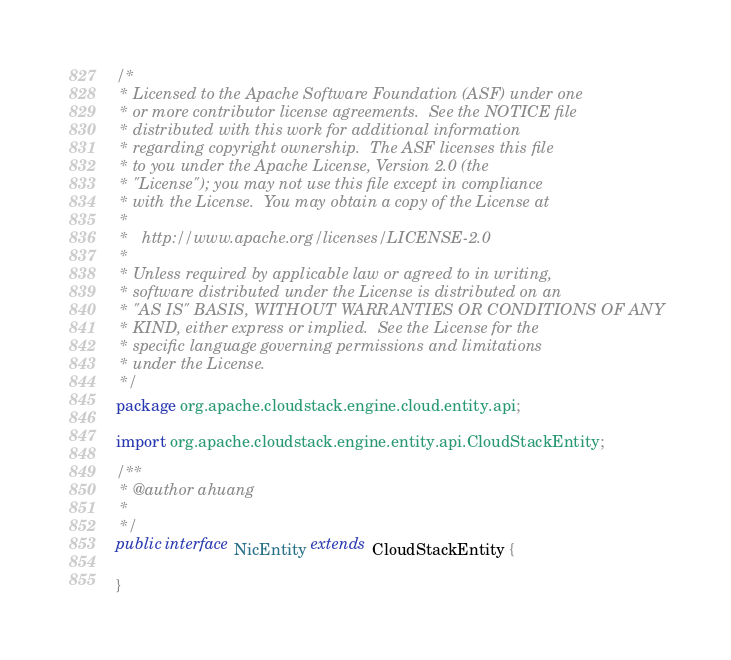Convert code to text. <code><loc_0><loc_0><loc_500><loc_500><_Java_>/*
 * Licensed to the Apache Software Foundation (ASF) under one
 * or more contributor license agreements.  See the NOTICE file
 * distributed with this work for additional information
 * regarding copyright ownership.  The ASF licenses this file
 * to you under the Apache License, Version 2.0 (the
 * "License"); you may not use this file except in compliance
 * with the License.  You may obtain a copy of the License at
 *
 *   http://www.apache.org/licenses/LICENSE-2.0
 *
 * Unless required by applicable law or agreed to in writing,
 * software distributed under the License is distributed on an
 * "AS IS" BASIS, WITHOUT WARRANTIES OR CONDITIONS OF ANY
 * KIND, either express or implied.  See the License for the
 * specific language governing permissions and limitations
 * under the License.
 */
package org.apache.cloudstack.engine.cloud.entity.api;

import org.apache.cloudstack.engine.entity.api.CloudStackEntity;

/**
 * @author ahuang
 *
 */
public interface NicEntity extends CloudStackEntity {

}
</code> 